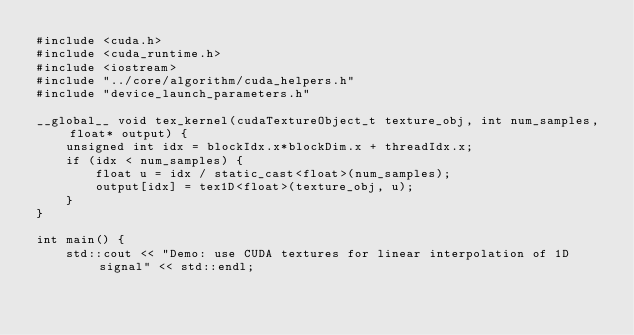Convert code to text. <code><loc_0><loc_0><loc_500><loc_500><_Cuda_>#include <cuda.h>
#include <cuda_runtime.h>
#include <iostream>
#include "../core/algorithm/cuda_helpers.h"
#include "device_launch_parameters.h"

__global__ void tex_kernel(cudaTextureObject_t texture_obj, int num_samples, float* output) {
    unsigned int idx = blockIdx.x*blockDim.x + threadIdx.x;
    if (idx < num_samples) {
        float u = idx / static_cast<float>(num_samples);
        output[idx] = tex1D<float>(texture_obj, u);
    }
}

int main() {
    std::cout << "Demo: use CUDA textures for linear interpolation of 1D signal" << std::endl;</code> 